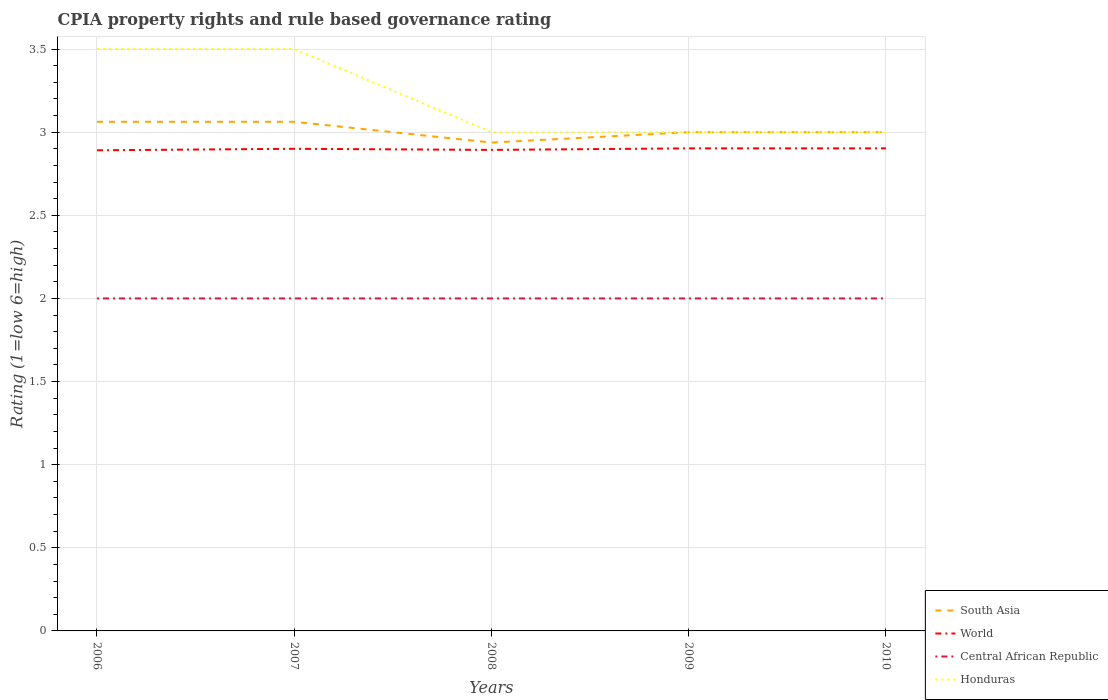How many different coloured lines are there?
Offer a very short reply. 4. Does the line corresponding to Honduras intersect with the line corresponding to Central African Republic?
Provide a short and direct response. No. Is the number of lines equal to the number of legend labels?
Keep it short and to the point. Yes. Across all years, what is the maximum CPIA rating in South Asia?
Keep it short and to the point. 2.94. In which year was the CPIA rating in World maximum?
Offer a very short reply. 2006. What is the total CPIA rating in Central African Republic in the graph?
Ensure brevity in your answer.  0. What is the difference between the highest and the second highest CPIA rating in Honduras?
Ensure brevity in your answer.  0.5. What is the difference between the highest and the lowest CPIA rating in World?
Your answer should be compact. 3. How many lines are there?
Your answer should be very brief. 4. How many years are there in the graph?
Keep it short and to the point. 5. Does the graph contain grids?
Ensure brevity in your answer.  Yes. How many legend labels are there?
Your answer should be very brief. 4. What is the title of the graph?
Your response must be concise. CPIA property rights and rule based governance rating. Does "Sierra Leone" appear as one of the legend labels in the graph?
Ensure brevity in your answer.  No. What is the label or title of the X-axis?
Offer a very short reply. Years. What is the Rating (1=low 6=high) of South Asia in 2006?
Offer a terse response. 3.06. What is the Rating (1=low 6=high) of World in 2006?
Your answer should be very brief. 2.89. What is the Rating (1=low 6=high) of Honduras in 2006?
Ensure brevity in your answer.  3.5. What is the Rating (1=low 6=high) in South Asia in 2007?
Provide a short and direct response. 3.06. What is the Rating (1=low 6=high) in South Asia in 2008?
Your response must be concise. 2.94. What is the Rating (1=low 6=high) of World in 2008?
Provide a short and direct response. 2.89. What is the Rating (1=low 6=high) of Central African Republic in 2008?
Your answer should be compact. 2. What is the Rating (1=low 6=high) of World in 2009?
Your answer should be compact. 2.9. What is the Rating (1=low 6=high) in Central African Republic in 2009?
Ensure brevity in your answer.  2. What is the Rating (1=low 6=high) of South Asia in 2010?
Make the answer very short. 3. What is the Rating (1=low 6=high) of World in 2010?
Your response must be concise. 2.9. Across all years, what is the maximum Rating (1=low 6=high) in South Asia?
Give a very brief answer. 3.06. Across all years, what is the maximum Rating (1=low 6=high) of World?
Your response must be concise. 2.9. Across all years, what is the maximum Rating (1=low 6=high) of Central African Republic?
Your answer should be compact. 2. Across all years, what is the minimum Rating (1=low 6=high) of South Asia?
Your answer should be very brief. 2.94. Across all years, what is the minimum Rating (1=low 6=high) of World?
Offer a very short reply. 2.89. Across all years, what is the minimum Rating (1=low 6=high) in Central African Republic?
Offer a very short reply. 2. Across all years, what is the minimum Rating (1=low 6=high) in Honduras?
Offer a terse response. 3. What is the total Rating (1=low 6=high) in South Asia in the graph?
Make the answer very short. 15.06. What is the total Rating (1=low 6=high) in World in the graph?
Ensure brevity in your answer.  14.49. What is the total Rating (1=low 6=high) in Central African Republic in the graph?
Make the answer very short. 10. What is the total Rating (1=low 6=high) in Honduras in the graph?
Make the answer very short. 16. What is the difference between the Rating (1=low 6=high) of World in 2006 and that in 2007?
Provide a succinct answer. -0.01. What is the difference between the Rating (1=low 6=high) of Central African Republic in 2006 and that in 2007?
Your answer should be very brief. 0. What is the difference between the Rating (1=low 6=high) of South Asia in 2006 and that in 2008?
Provide a short and direct response. 0.12. What is the difference between the Rating (1=low 6=high) in World in 2006 and that in 2008?
Ensure brevity in your answer.  -0. What is the difference between the Rating (1=low 6=high) in South Asia in 2006 and that in 2009?
Provide a short and direct response. 0.06. What is the difference between the Rating (1=low 6=high) of World in 2006 and that in 2009?
Make the answer very short. -0.01. What is the difference between the Rating (1=low 6=high) of South Asia in 2006 and that in 2010?
Ensure brevity in your answer.  0.06. What is the difference between the Rating (1=low 6=high) of World in 2006 and that in 2010?
Provide a short and direct response. -0.01. What is the difference between the Rating (1=low 6=high) of Central African Republic in 2006 and that in 2010?
Give a very brief answer. 0. What is the difference between the Rating (1=low 6=high) in South Asia in 2007 and that in 2008?
Ensure brevity in your answer.  0.12. What is the difference between the Rating (1=low 6=high) of World in 2007 and that in 2008?
Keep it short and to the point. 0.01. What is the difference between the Rating (1=low 6=high) in Central African Republic in 2007 and that in 2008?
Your answer should be very brief. 0. What is the difference between the Rating (1=low 6=high) in Honduras in 2007 and that in 2008?
Ensure brevity in your answer.  0.5. What is the difference between the Rating (1=low 6=high) in South Asia in 2007 and that in 2009?
Your answer should be compact. 0.06. What is the difference between the Rating (1=low 6=high) of World in 2007 and that in 2009?
Provide a succinct answer. -0. What is the difference between the Rating (1=low 6=high) of Central African Republic in 2007 and that in 2009?
Make the answer very short. 0. What is the difference between the Rating (1=low 6=high) in Honduras in 2007 and that in 2009?
Offer a terse response. 0.5. What is the difference between the Rating (1=low 6=high) of South Asia in 2007 and that in 2010?
Provide a succinct answer. 0.06. What is the difference between the Rating (1=low 6=high) of World in 2007 and that in 2010?
Provide a short and direct response. -0. What is the difference between the Rating (1=low 6=high) in Central African Republic in 2007 and that in 2010?
Give a very brief answer. 0. What is the difference between the Rating (1=low 6=high) of South Asia in 2008 and that in 2009?
Make the answer very short. -0.06. What is the difference between the Rating (1=low 6=high) in World in 2008 and that in 2009?
Make the answer very short. -0.01. What is the difference between the Rating (1=low 6=high) of Central African Republic in 2008 and that in 2009?
Give a very brief answer. 0. What is the difference between the Rating (1=low 6=high) of South Asia in 2008 and that in 2010?
Ensure brevity in your answer.  -0.06. What is the difference between the Rating (1=low 6=high) in World in 2008 and that in 2010?
Offer a terse response. -0.01. What is the difference between the Rating (1=low 6=high) of Central African Republic in 2008 and that in 2010?
Keep it short and to the point. 0. What is the difference between the Rating (1=low 6=high) of South Asia in 2009 and that in 2010?
Keep it short and to the point. 0. What is the difference between the Rating (1=low 6=high) in Central African Republic in 2009 and that in 2010?
Make the answer very short. 0. What is the difference between the Rating (1=low 6=high) of Honduras in 2009 and that in 2010?
Offer a terse response. 0. What is the difference between the Rating (1=low 6=high) of South Asia in 2006 and the Rating (1=low 6=high) of World in 2007?
Provide a succinct answer. 0.16. What is the difference between the Rating (1=low 6=high) of South Asia in 2006 and the Rating (1=low 6=high) of Central African Republic in 2007?
Your answer should be very brief. 1.06. What is the difference between the Rating (1=low 6=high) of South Asia in 2006 and the Rating (1=low 6=high) of Honduras in 2007?
Make the answer very short. -0.44. What is the difference between the Rating (1=low 6=high) in World in 2006 and the Rating (1=low 6=high) in Central African Republic in 2007?
Offer a very short reply. 0.89. What is the difference between the Rating (1=low 6=high) in World in 2006 and the Rating (1=low 6=high) in Honduras in 2007?
Make the answer very short. -0.61. What is the difference between the Rating (1=low 6=high) in Central African Republic in 2006 and the Rating (1=low 6=high) in Honduras in 2007?
Provide a short and direct response. -1.5. What is the difference between the Rating (1=low 6=high) of South Asia in 2006 and the Rating (1=low 6=high) of World in 2008?
Ensure brevity in your answer.  0.17. What is the difference between the Rating (1=low 6=high) of South Asia in 2006 and the Rating (1=low 6=high) of Central African Republic in 2008?
Give a very brief answer. 1.06. What is the difference between the Rating (1=low 6=high) of South Asia in 2006 and the Rating (1=low 6=high) of Honduras in 2008?
Your answer should be compact. 0.06. What is the difference between the Rating (1=low 6=high) in World in 2006 and the Rating (1=low 6=high) in Central African Republic in 2008?
Make the answer very short. 0.89. What is the difference between the Rating (1=low 6=high) in World in 2006 and the Rating (1=low 6=high) in Honduras in 2008?
Offer a very short reply. -0.11. What is the difference between the Rating (1=low 6=high) of Central African Republic in 2006 and the Rating (1=low 6=high) of Honduras in 2008?
Make the answer very short. -1. What is the difference between the Rating (1=low 6=high) of South Asia in 2006 and the Rating (1=low 6=high) of World in 2009?
Your answer should be very brief. 0.16. What is the difference between the Rating (1=low 6=high) of South Asia in 2006 and the Rating (1=low 6=high) of Central African Republic in 2009?
Keep it short and to the point. 1.06. What is the difference between the Rating (1=low 6=high) in South Asia in 2006 and the Rating (1=low 6=high) in Honduras in 2009?
Your answer should be very brief. 0.06. What is the difference between the Rating (1=low 6=high) of World in 2006 and the Rating (1=low 6=high) of Central African Republic in 2009?
Offer a very short reply. 0.89. What is the difference between the Rating (1=low 6=high) in World in 2006 and the Rating (1=low 6=high) in Honduras in 2009?
Your answer should be compact. -0.11. What is the difference between the Rating (1=low 6=high) in South Asia in 2006 and the Rating (1=low 6=high) in World in 2010?
Your answer should be compact. 0.16. What is the difference between the Rating (1=low 6=high) of South Asia in 2006 and the Rating (1=low 6=high) of Central African Republic in 2010?
Keep it short and to the point. 1.06. What is the difference between the Rating (1=low 6=high) of South Asia in 2006 and the Rating (1=low 6=high) of Honduras in 2010?
Provide a succinct answer. 0.06. What is the difference between the Rating (1=low 6=high) of World in 2006 and the Rating (1=low 6=high) of Central African Republic in 2010?
Provide a short and direct response. 0.89. What is the difference between the Rating (1=low 6=high) of World in 2006 and the Rating (1=low 6=high) of Honduras in 2010?
Offer a terse response. -0.11. What is the difference between the Rating (1=low 6=high) in South Asia in 2007 and the Rating (1=low 6=high) in World in 2008?
Provide a short and direct response. 0.17. What is the difference between the Rating (1=low 6=high) in South Asia in 2007 and the Rating (1=low 6=high) in Central African Republic in 2008?
Your answer should be very brief. 1.06. What is the difference between the Rating (1=low 6=high) of South Asia in 2007 and the Rating (1=low 6=high) of Honduras in 2008?
Your response must be concise. 0.06. What is the difference between the Rating (1=low 6=high) in World in 2007 and the Rating (1=low 6=high) in Honduras in 2008?
Keep it short and to the point. -0.1. What is the difference between the Rating (1=low 6=high) in Central African Republic in 2007 and the Rating (1=low 6=high) in Honduras in 2008?
Provide a short and direct response. -1. What is the difference between the Rating (1=low 6=high) in South Asia in 2007 and the Rating (1=low 6=high) in World in 2009?
Keep it short and to the point. 0.16. What is the difference between the Rating (1=low 6=high) in South Asia in 2007 and the Rating (1=low 6=high) in Central African Republic in 2009?
Provide a short and direct response. 1.06. What is the difference between the Rating (1=low 6=high) in South Asia in 2007 and the Rating (1=low 6=high) in Honduras in 2009?
Give a very brief answer. 0.06. What is the difference between the Rating (1=low 6=high) of World in 2007 and the Rating (1=low 6=high) of Central African Republic in 2009?
Offer a terse response. 0.9. What is the difference between the Rating (1=low 6=high) of Central African Republic in 2007 and the Rating (1=low 6=high) of Honduras in 2009?
Make the answer very short. -1. What is the difference between the Rating (1=low 6=high) of South Asia in 2007 and the Rating (1=low 6=high) of World in 2010?
Give a very brief answer. 0.16. What is the difference between the Rating (1=low 6=high) in South Asia in 2007 and the Rating (1=low 6=high) in Central African Republic in 2010?
Your answer should be compact. 1.06. What is the difference between the Rating (1=low 6=high) of South Asia in 2007 and the Rating (1=low 6=high) of Honduras in 2010?
Provide a succinct answer. 0.06. What is the difference between the Rating (1=low 6=high) in South Asia in 2008 and the Rating (1=low 6=high) in World in 2009?
Provide a short and direct response. 0.03. What is the difference between the Rating (1=low 6=high) in South Asia in 2008 and the Rating (1=low 6=high) in Central African Republic in 2009?
Offer a terse response. 0.94. What is the difference between the Rating (1=low 6=high) of South Asia in 2008 and the Rating (1=low 6=high) of Honduras in 2009?
Keep it short and to the point. -0.06. What is the difference between the Rating (1=low 6=high) in World in 2008 and the Rating (1=low 6=high) in Central African Republic in 2009?
Provide a short and direct response. 0.89. What is the difference between the Rating (1=low 6=high) in World in 2008 and the Rating (1=low 6=high) in Honduras in 2009?
Your answer should be compact. -0.11. What is the difference between the Rating (1=low 6=high) in South Asia in 2008 and the Rating (1=low 6=high) in World in 2010?
Offer a very short reply. 0.03. What is the difference between the Rating (1=low 6=high) in South Asia in 2008 and the Rating (1=low 6=high) in Central African Republic in 2010?
Make the answer very short. 0.94. What is the difference between the Rating (1=low 6=high) of South Asia in 2008 and the Rating (1=low 6=high) of Honduras in 2010?
Offer a very short reply. -0.06. What is the difference between the Rating (1=low 6=high) in World in 2008 and the Rating (1=low 6=high) in Central African Republic in 2010?
Offer a terse response. 0.89. What is the difference between the Rating (1=low 6=high) of World in 2008 and the Rating (1=low 6=high) of Honduras in 2010?
Your response must be concise. -0.11. What is the difference between the Rating (1=low 6=high) of Central African Republic in 2008 and the Rating (1=low 6=high) of Honduras in 2010?
Make the answer very short. -1. What is the difference between the Rating (1=low 6=high) in South Asia in 2009 and the Rating (1=low 6=high) in World in 2010?
Give a very brief answer. 0.1. What is the difference between the Rating (1=low 6=high) of South Asia in 2009 and the Rating (1=low 6=high) of Honduras in 2010?
Your answer should be very brief. 0. What is the difference between the Rating (1=low 6=high) in World in 2009 and the Rating (1=low 6=high) in Central African Republic in 2010?
Keep it short and to the point. 0.9. What is the difference between the Rating (1=low 6=high) of World in 2009 and the Rating (1=low 6=high) of Honduras in 2010?
Provide a succinct answer. -0.1. What is the difference between the Rating (1=low 6=high) in Central African Republic in 2009 and the Rating (1=low 6=high) in Honduras in 2010?
Provide a short and direct response. -1. What is the average Rating (1=low 6=high) in South Asia per year?
Provide a short and direct response. 3.01. What is the average Rating (1=low 6=high) of World per year?
Provide a short and direct response. 2.9. In the year 2006, what is the difference between the Rating (1=low 6=high) of South Asia and Rating (1=low 6=high) of World?
Provide a succinct answer. 0.17. In the year 2006, what is the difference between the Rating (1=low 6=high) of South Asia and Rating (1=low 6=high) of Central African Republic?
Give a very brief answer. 1.06. In the year 2006, what is the difference between the Rating (1=low 6=high) in South Asia and Rating (1=low 6=high) in Honduras?
Keep it short and to the point. -0.44. In the year 2006, what is the difference between the Rating (1=low 6=high) in World and Rating (1=low 6=high) in Central African Republic?
Your answer should be compact. 0.89. In the year 2006, what is the difference between the Rating (1=low 6=high) in World and Rating (1=low 6=high) in Honduras?
Offer a very short reply. -0.61. In the year 2006, what is the difference between the Rating (1=low 6=high) in Central African Republic and Rating (1=low 6=high) in Honduras?
Keep it short and to the point. -1.5. In the year 2007, what is the difference between the Rating (1=low 6=high) in South Asia and Rating (1=low 6=high) in World?
Offer a terse response. 0.16. In the year 2007, what is the difference between the Rating (1=low 6=high) in South Asia and Rating (1=low 6=high) in Honduras?
Offer a terse response. -0.44. In the year 2007, what is the difference between the Rating (1=low 6=high) in World and Rating (1=low 6=high) in Central African Republic?
Your answer should be very brief. 0.9. In the year 2008, what is the difference between the Rating (1=low 6=high) in South Asia and Rating (1=low 6=high) in World?
Ensure brevity in your answer.  0.04. In the year 2008, what is the difference between the Rating (1=low 6=high) in South Asia and Rating (1=low 6=high) in Honduras?
Provide a short and direct response. -0.06. In the year 2008, what is the difference between the Rating (1=low 6=high) of World and Rating (1=low 6=high) of Central African Republic?
Give a very brief answer. 0.89. In the year 2008, what is the difference between the Rating (1=low 6=high) of World and Rating (1=low 6=high) of Honduras?
Provide a short and direct response. -0.11. In the year 2008, what is the difference between the Rating (1=low 6=high) of Central African Republic and Rating (1=low 6=high) of Honduras?
Your answer should be very brief. -1. In the year 2009, what is the difference between the Rating (1=low 6=high) in South Asia and Rating (1=low 6=high) in World?
Offer a very short reply. 0.1. In the year 2009, what is the difference between the Rating (1=low 6=high) in South Asia and Rating (1=low 6=high) in Honduras?
Keep it short and to the point. 0. In the year 2009, what is the difference between the Rating (1=low 6=high) in World and Rating (1=low 6=high) in Central African Republic?
Offer a very short reply. 0.9. In the year 2009, what is the difference between the Rating (1=low 6=high) in World and Rating (1=low 6=high) in Honduras?
Give a very brief answer. -0.1. In the year 2009, what is the difference between the Rating (1=low 6=high) of Central African Republic and Rating (1=low 6=high) of Honduras?
Offer a terse response. -1. In the year 2010, what is the difference between the Rating (1=low 6=high) of South Asia and Rating (1=low 6=high) of World?
Give a very brief answer. 0.1. In the year 2010, what is the difference between the Rating (1=low 6=high) in South Asia and Rating (1=low 6=high) in Central African Republic?
Your answer should be very brief. 1. In the year 2010, what is the difference between the Rating (1=low 6=high) of South Asia and Rating (1=low 6=high) of Honduras?
Your answer should be very brief. 0. In the year 2010, what is the difference between the Rating (1=low 6=high) in World and Rating (1=low 6=high) in Central African Republic?
Your response must be concise. 0.9. In the year 2010, what is the difference between the Rating (1=low 6=high) of World and Rating (1=low 6=high) of Honduras?
Provide a short and direct response. -0.1. What is the ratio of the Rating (1=low 6=high) in Central African Republic in 2006 to that in 2007?
Offer a very short reply. 1. What is the ratio of the Rating (1=low 6=high) in Honduras in 2006 to that in 2007?
Ensure brevity in your answer.  1. What is the ratio of the Rating (1=low 6=high) in South Asia in 2006 to that in 2008?
Your answer should be compact. 1.04. What is the ratio of the Rating (1=low 6=high) of Honduras in 2006 to that in 2008?
Make the answer very short. 1.17. What is the ratio of the Rating (1=low 6=high) of South Asia in 2006 to that in 2009?
Your answer should be very brief. 1.02. What is the ratio of the Rating (1=low 6=high) of World in 2006 to that in 2009?
Offer a terse response. 1. What is the ratio of the Rating (1=low 6=high) of South Asia in 2006 to that in 2010?
Give a very brief answer. 1.02. What is the ratio of the Rating (1=low 6=high) in Central African Republic in 2006 to that in 2010?
Keep it short and to the point. 1. What is the ratio of the Rating (1=low 6=high) of Honduras in 2006 to that in 2010?
Make the answer very short. 1.17. What is the ratio of the Rating (1=low 6=high) in South Asia in 2007 to that in 2008?
Provide a succinct answer. 1.04. What is the ratio of the Rating (1=low 6=high) in Central African Republic in 2007 to that in 2008?
Give a very brief answer. 1. What is the ratio of the Rating (1=low 6=high) in South Asia in 2007 to that in 2009?
Your answer should be compact. 1.02. What is the ratio of the Rating (1=low 6=high) of Central African Republic in 2007 to that in 2009?
Offer a very short reply. 1. What is the ratio of the Rating (1=low 6=high) of South Asia in 2007 to that in 2010?
Offer a very short reply. 1.02. What is the ratio of the Rating (1=low 6=high) of Central African Republic in 2007 to that in 2010?
Ensure brevity in your answer.  1. What is the ratio of the Rating (1=low 6=high) in South Asia in 2008 to that in 2009?
Offer a very short reply. 0.98. What is the ratio of the Rating (1=low 6=high) in World in 2008 to that in 2009?
Provide a short and direct response. 1. What is the ratio of the Rating (1=low 6=high) in South Asia in 2008 to that in 2010?
Your response must be concise. 0.98. What is the ratio of the Rating (1=low 6=high) of Central African Republic in 2008 to that in 2010?
Offer a terse response. 1. What is the ratio of the Rating (1=low 6=high) of South Asia in 2009 to that in 2010?
Your answer should be compact. 1. What is the ratio of the Rating (1=low 6=high) of Honduras in 2009 to that in 2010?
Offer a very short reply. 1. What is the difference between the highest and the second highest Rating (1=low 6=high) of South Asia?
Your response must be concise. 0. What is the difference between the highest and the lowest Rating (1=low 6=high) in South Asia?
Your answer should be compact. 0.12. What is the difference between the highest and the lowest Rating (1=low 6=high) in World?
Keep it short and to the point. 0.01. 